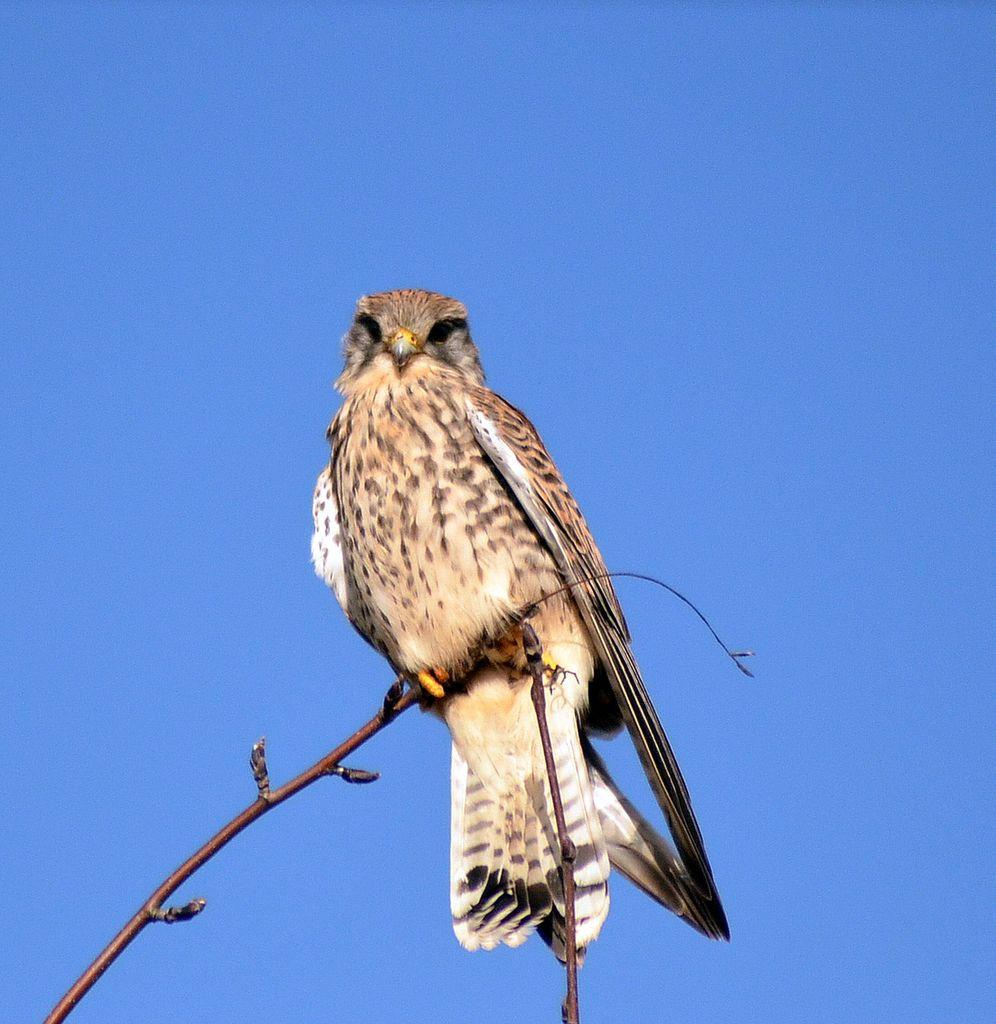What animal is featured in the picture? There is an eagle in the picture. Where is the eagle positioned in the image? The eagle is standing on the stem of a plant. What can be seen in the background of the picture? The sky is visible in the picture. What is the color of the sky in the image? The sky is blue in color. What type of note is the eagle holding in its talons in the image? There is no note present in the image; the eagle is standing on the stem of a plant. 